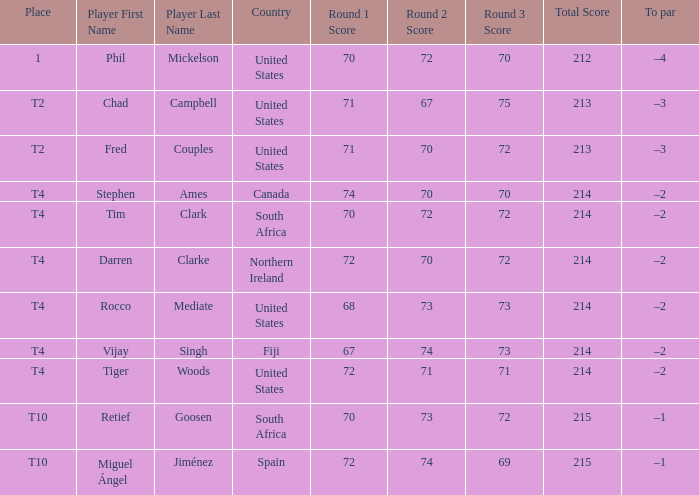What is the home country of chad campbell? United States. 